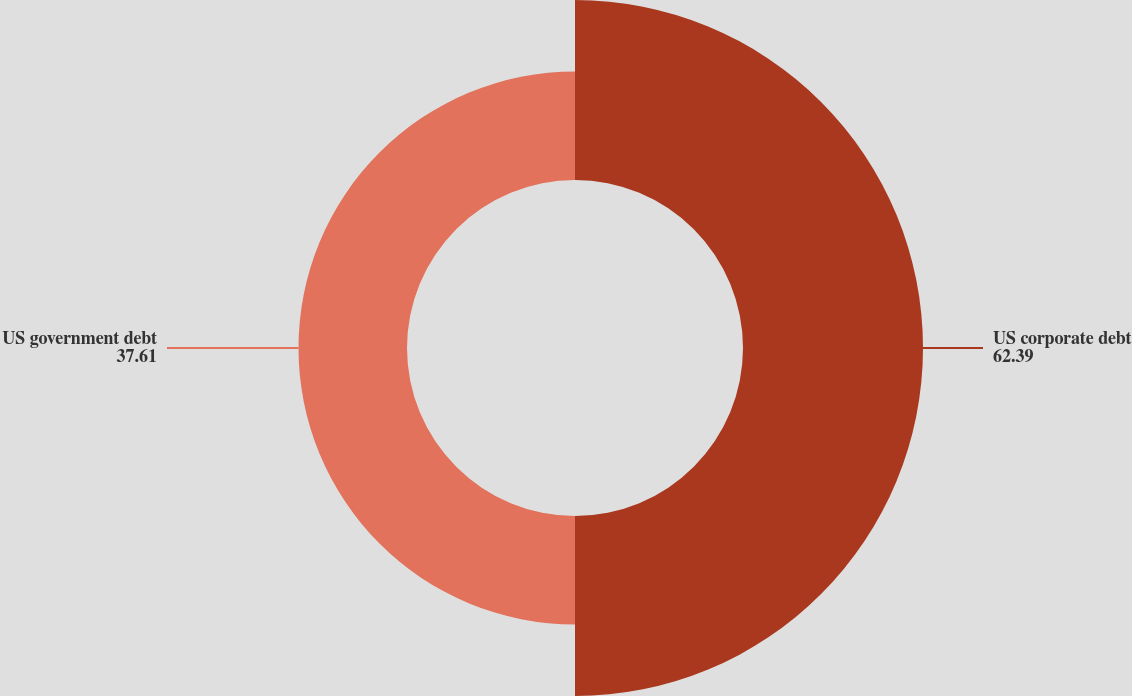Convert chart to OTSL. <chart><loc_0><loc_0><loc_500><loc_500><pie_chart><fcel>US corporate debt<fcel>US government debt<nl><fcel>62.39%<fcel>37.61%<nl></chart> 